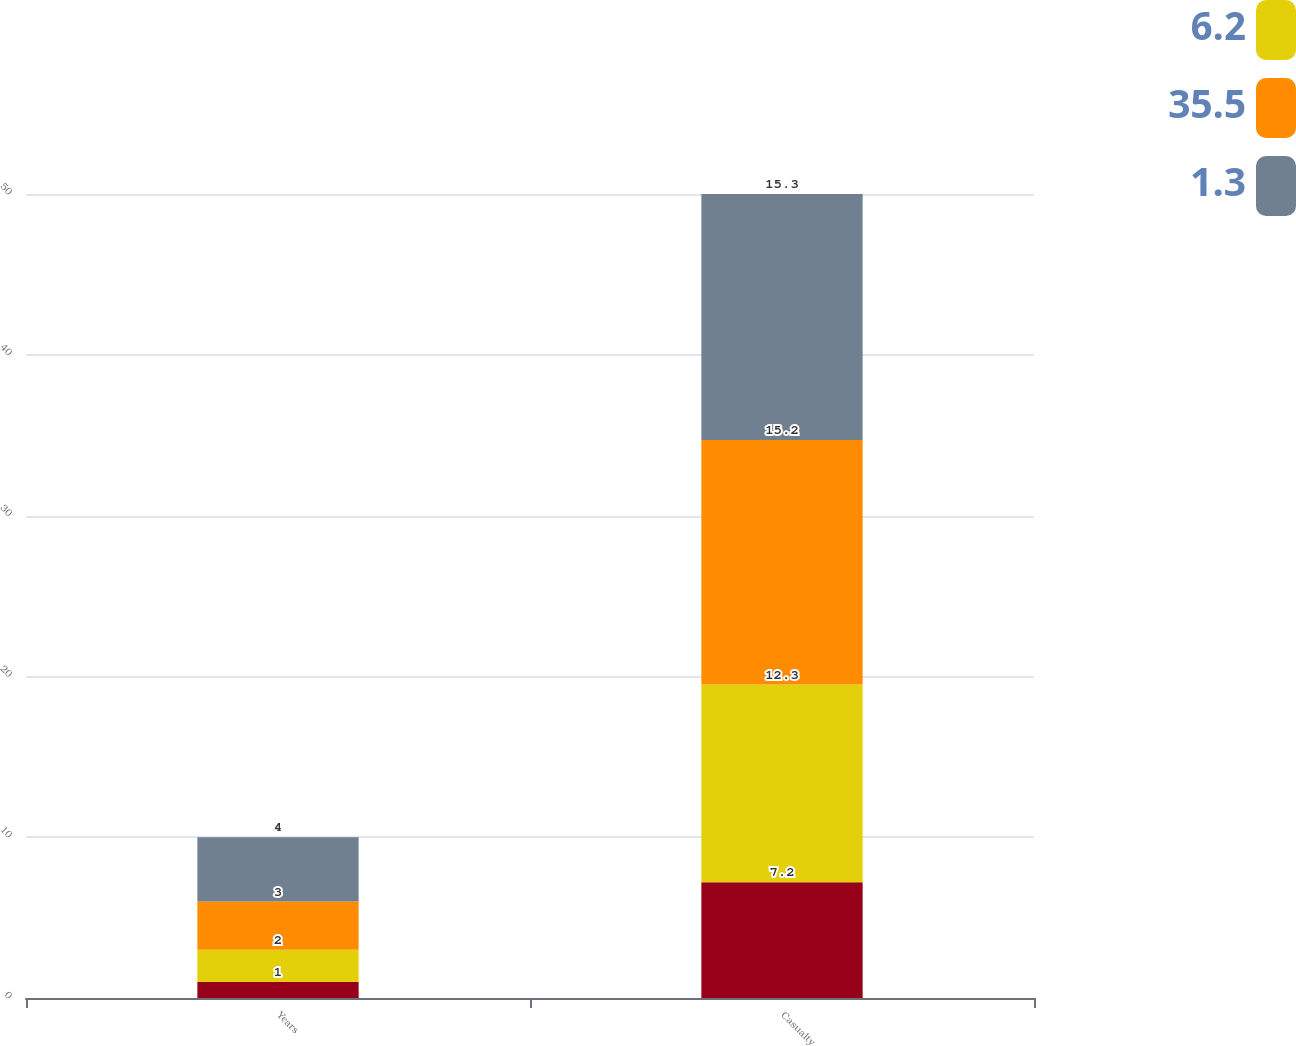Convert chart. <chart><loc_0><loc_0><loc_500><loc_500><stacked_bar_chart><ecel><fcel>Years<fcel>Casualty<nl><fcel>nan<fcel>1<fcel>7.2<nl><fcel>6.2<fcel>2<fcel>12.3<nl><fcel>35.5<fcel>3<fcel>15.2<nl><fcel>1.3<fcel>4<fcel>15.3<nl></chart> 